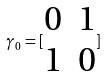Convert formula to latex. <formula><loc_0><loc_0><loc_500><loc_500>\gamma _ { 0 } = [ \begin{matrix} 0 & 1 \\ 1 & 0 \end{matrix} ]</formula> 